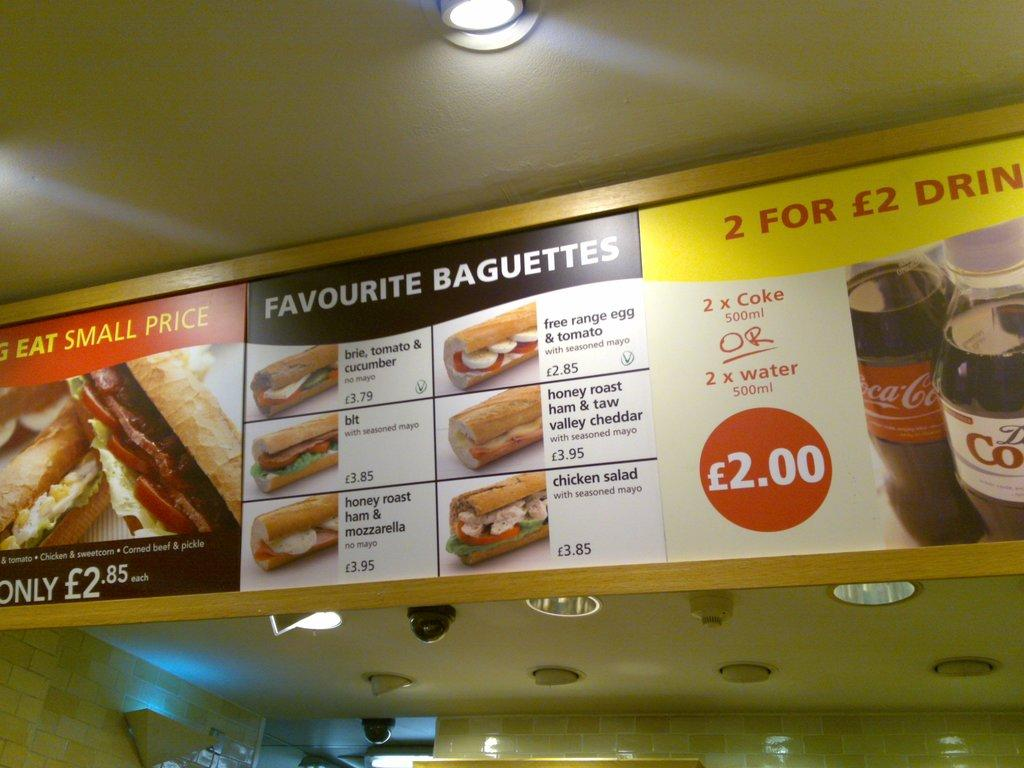What is the main object in the center of the image? There is a board in the center of the image. What can be seen at the top of the image? There are lights at the top of the image. What is visible in the background of the image? There is a wall in the background of the image. What type of cap is the eggnog wearing in the image? There is no eggnog or cap present in the image. 